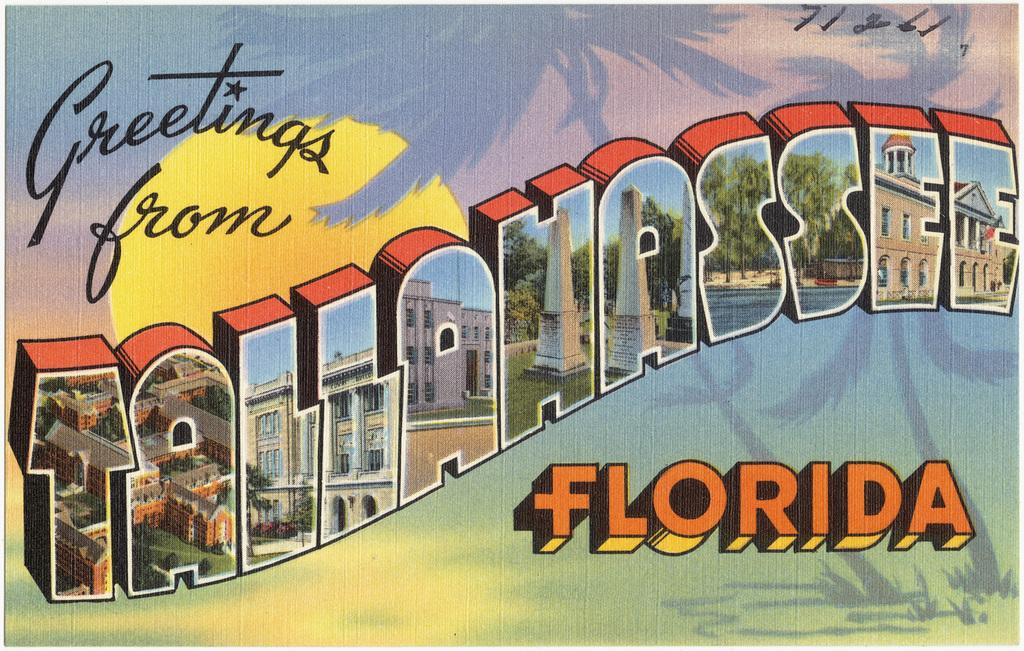<image>
Offer a succinct explanation of the picture presented. Tallahassee, Florida likes to gives small glimpse of their state and send greetings.. 